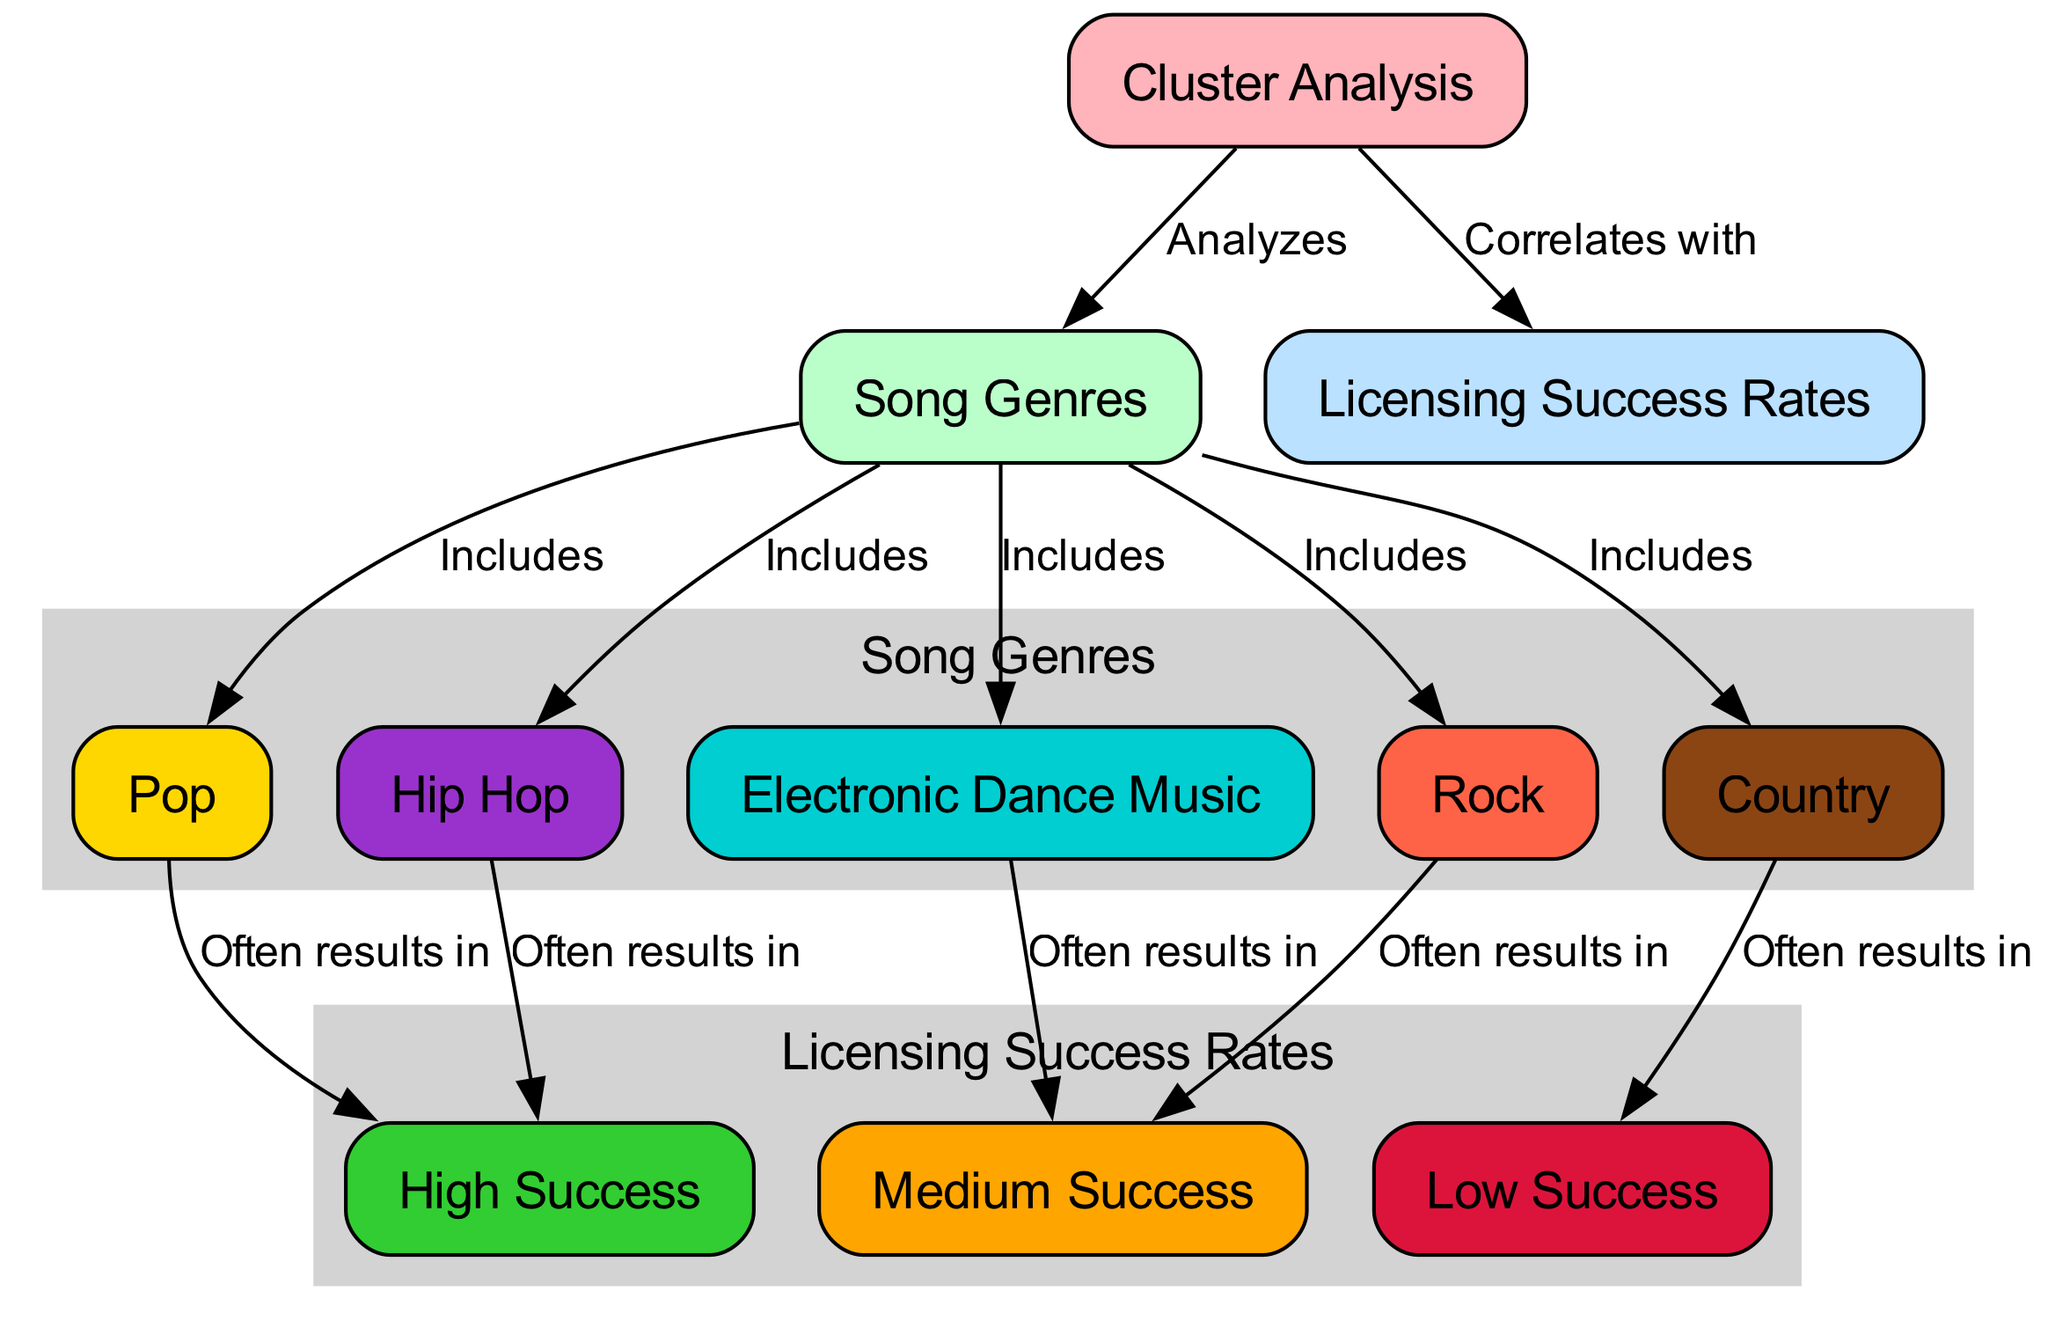What is the main focus of the cluster analysis? The main focus of the cluster analysis is to analyze song genres. This can be identified by looking at the central node labeled "Cluster Analysis," which is directly connected to the node labeled "Song Genres."
Answer: Analyze song genres How many song genres are included in the analysis? The number of song genres included can be counted from the edges connecting "Song Genres" to its included sub-genres. There are five sub-genre nodes: Pop, Rock, Hip Hop, EDM, and Country.
Answer: Five Which genre is often associated with high licensing success? To find which genre is often associated with high licensing success, we look for the edge connections leading to the "High Success" node. The genres connected to "High Success" are Pop and Hip Hop.
Answer: Pop and Hip Hop What is the relationship between Rock and Moderate Success? The relationship is defined by the edge that indicates Rock often results in Medium Success. This means that Rock songs generally have a moderate chance of achieving licensing success based on the diagram's connections.
Answer: Often results in Medium Success How many licensing success categories are represented in the diagram? The number of licensing success categories can be seen by counting the edges connected to the "Licensing Success Rates." There are three categories: High Success, Medium Success, and Low Success.
Answer: Three Which genre has the lowest likelihood of licensing success? The genre that has the lowest likelihood of licensing success is Country; the edge from Country leads to the Low Success node, indicating a trend toward lower success rates for this genre.
Answer: Country What colors represent the different nodes for song genres in the diagram? Each genre node is associated with a different color: Pop is Gold, Rock is Tomato, Hip Hop is Dark Orchid, EDM is Dark Turquoise, and Country is Saddle Brown. This can be deduced from the custom node colors applied in the diagram.
Answer: Gold, Tomato, Dark Orchid, Dark Turquoise, Saddle Brown How does cluster analysis correlate with licensing success? The correlation is explicit in the edges extending from the "Cluster Analysis" node to the "Licensing Success Rates" node, indicating a direct relationship between the analysis of song genres and their corresponding success rates in licensing.
Answer: Correlates with 